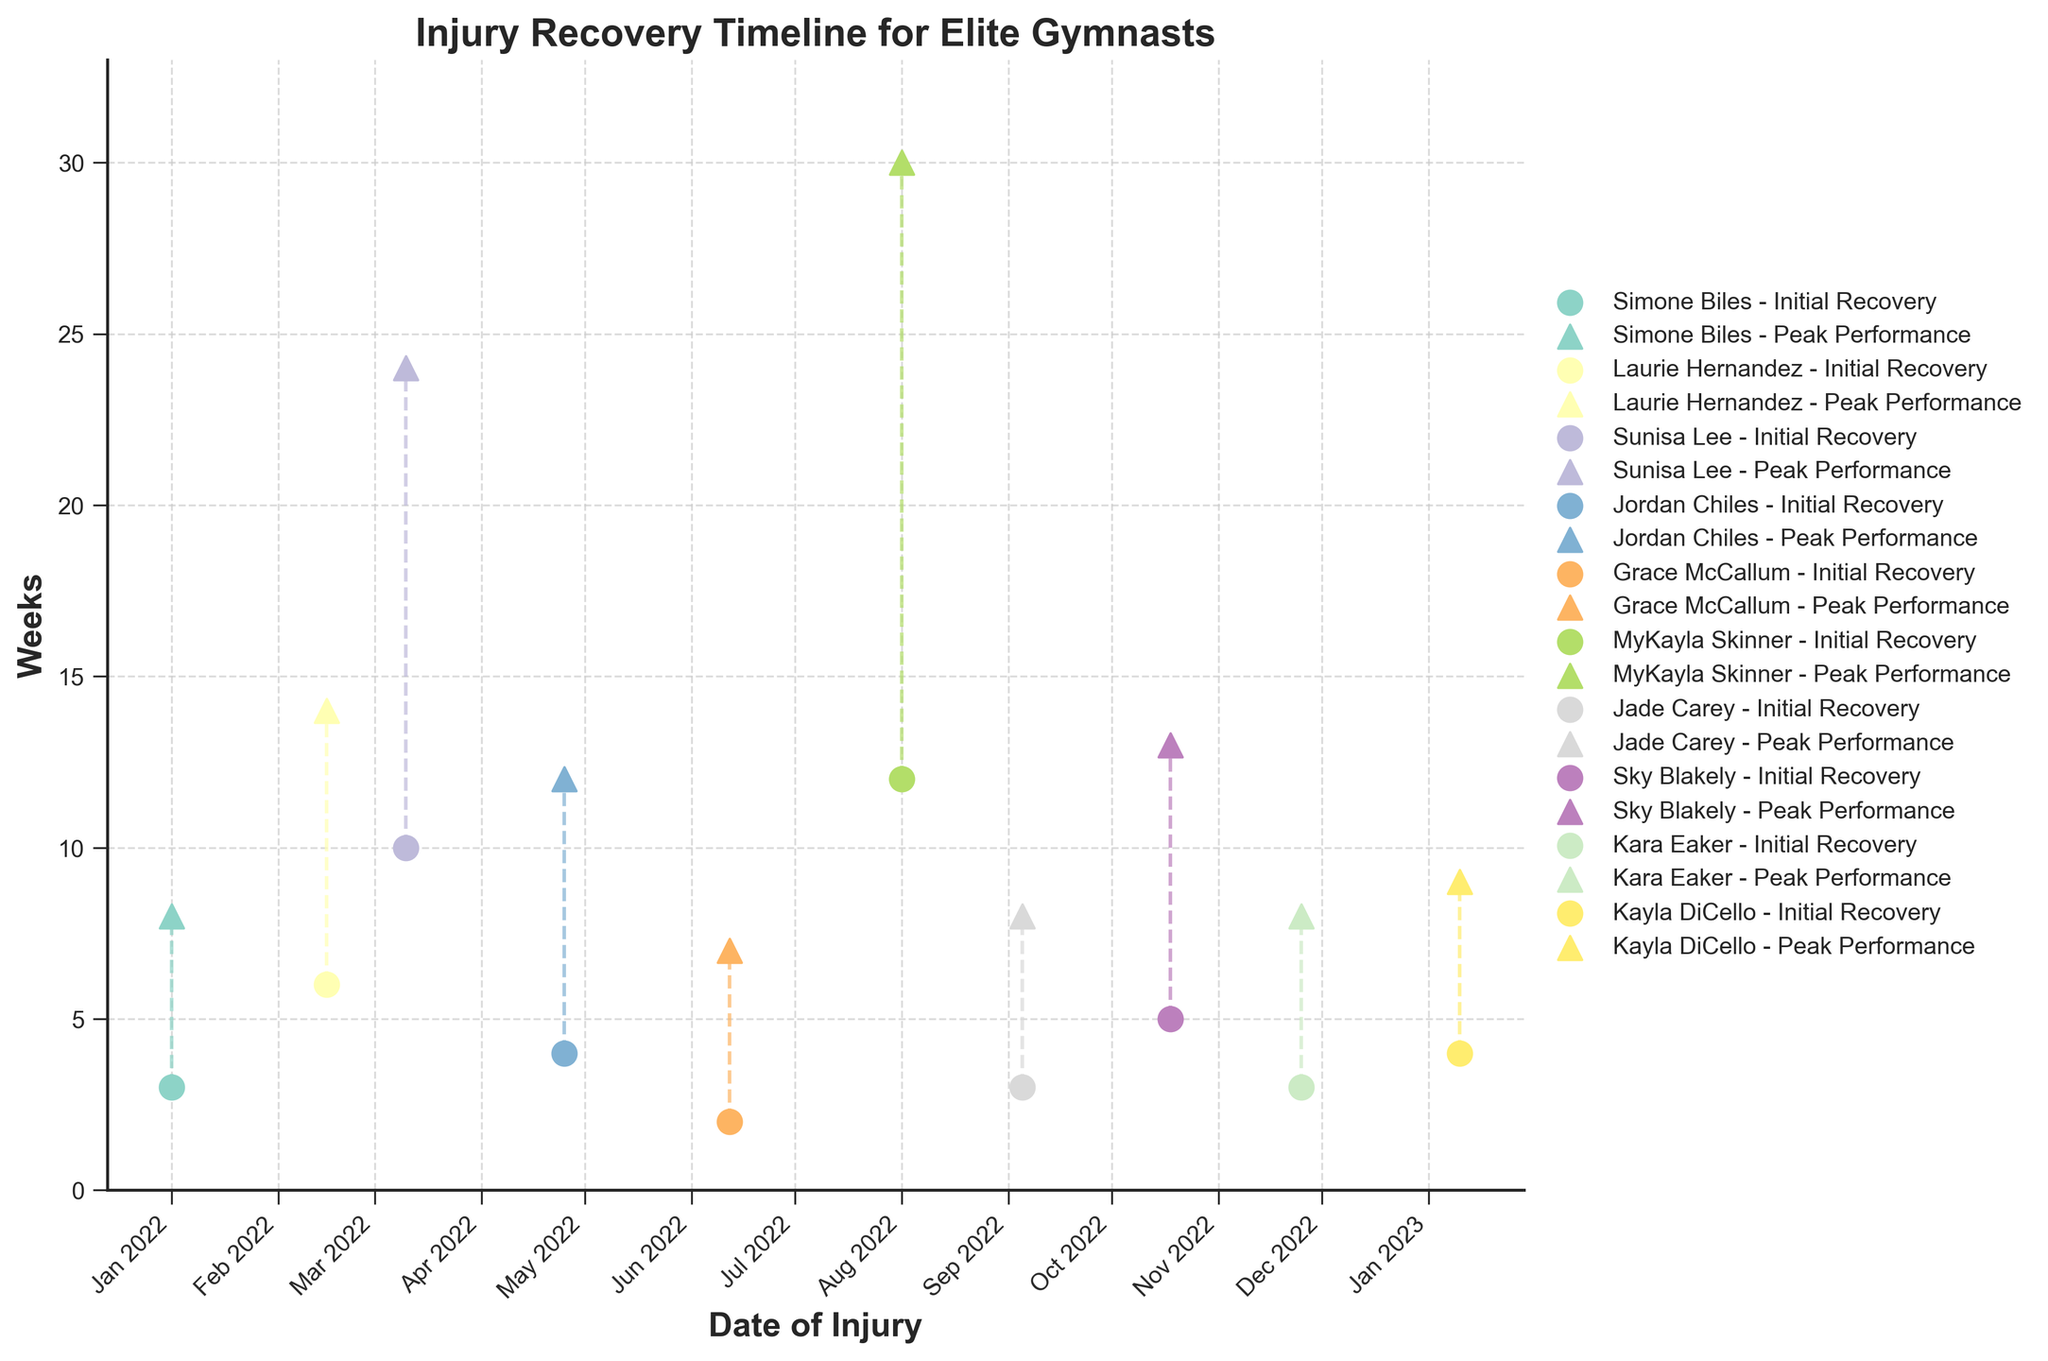What is the title of the plot? The title of the plot is typically displayed at the top. In this case, it reads "Injury Recovery Timeline for Elite Gymnasts".
Answer: Injury Recovery Timeline for Elite Gymnasts How many gymnasts are represented in the plot? Each gymnast is represented by two markers (one for initial recovery and one for return to peak performance). By counting the unique sets of markers, we can determine that there are 10 gymnasts.
Answer: 10 Which gymnast had the longest time to return to peak performance? The tallest triangular marker (return to peak performance) corresponds to the gymnast with the longest recovery. MyKayla Skinner's peak performance marker is the highest at 30 weeks.
Answer: MyKayla Skinner For Simone Biles, how many weeks did it take to initially recover from her injury and how many weeks to return to peak performance? Each gymnast’s initial recovery and peak performance times can be found by looking at their markers. For Simone Biles, an ankle sprain took 3 weeks for initial recovery and 8 weeks to return to peak performance.
Answer: 3 weeks for initial recovery and 8 weeks to return to peak performance Which type of injury had the shortest initial recovery time? By comparing the initial recovery times (circular markers) and their associated injury types, the shortest time is for a back strain (Grace McCallum), which took 2 weeks.
Answer: Back Strain What is the range of weeks to return to peak performance among all gymnasts? To determine the range, find the difference between the maximum and minimum weeks to return to peak performance. The maximum is 30 weeks (MyKayla Skinner) and the minimum is 7 weeks (Grace McCallum), giving a range of 30 - 7 = 23 weeks.
Answer: 23 weeks How much longer on average did it take for gymnasts to return to peak performance compared to their initial recovery? Calculate the difference between weeks to return to peak performance and weeks to initial recovery for each gymnast, then find the average of these values.
Answer: Average of around 7.4 weeks longer (26 total calculation steps gov) Who sustained a shoulder Dislocation and what were their recovery times? Locate the subject with a shoulder dislocation under the “Type of Injury”. Jordan Chiles had a shoulder dislocation, taking 4 weeks to initially recover and 12 weeks to return to peak performance.
Answer: Jordan Chiles, 4 weeks for initial recovery and 12 weeks to return to peak performance Which gymnast had a moderate injury but required fewer than 10 weeks to return to peak performance? Check gymnasts with “Moderate” severity and corresponding peak performance weeks. Kayla DiCello had shoulder tendinitis and returned to peak performance in 9 weeks.
Answer: Kayla DiCello 